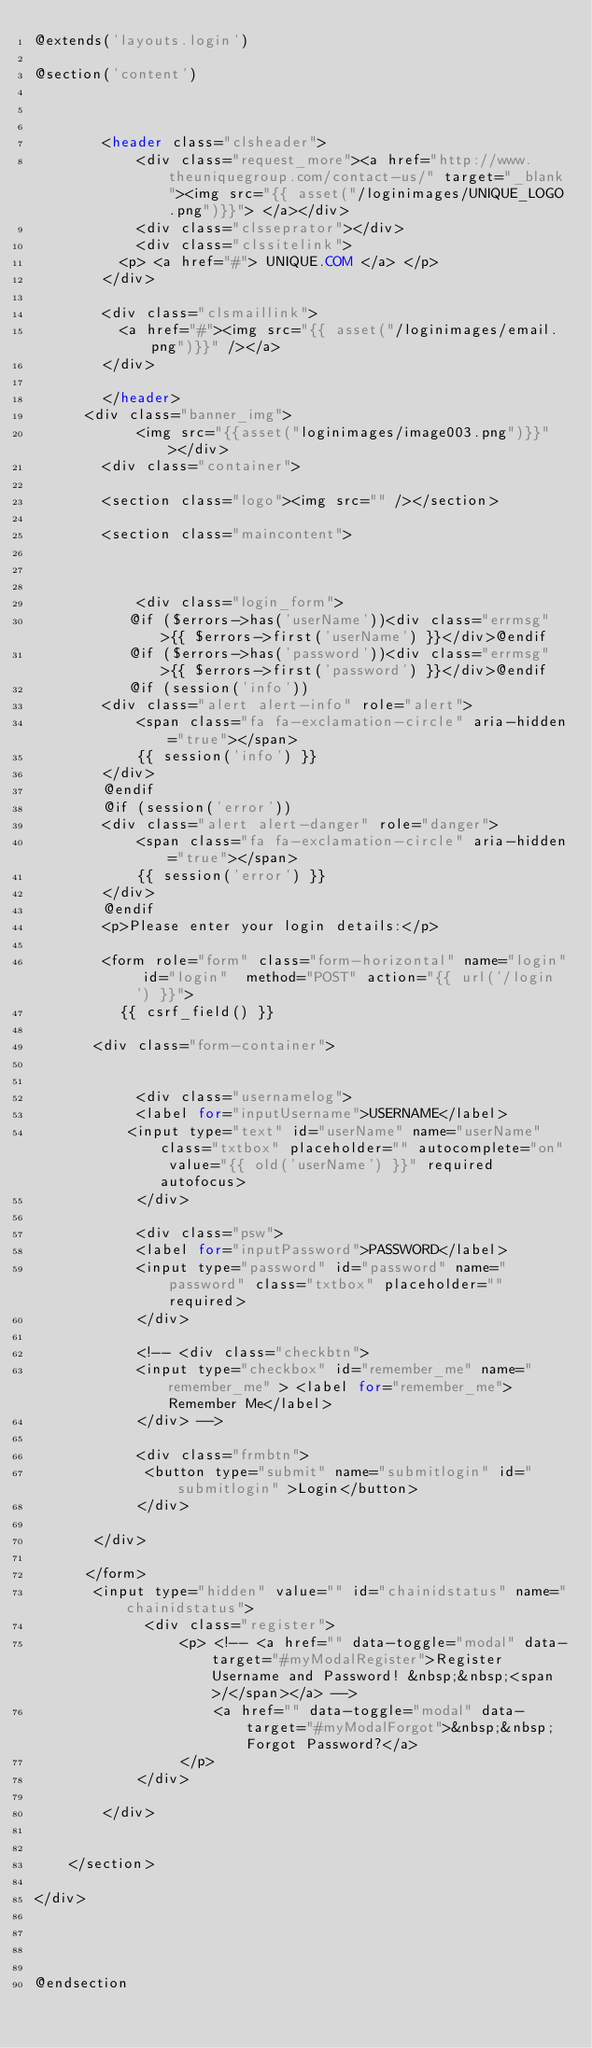Convert code to text. <code><loc_0><loc_0><loc_500><loc_500><_PHP_>@extends('layouts.login')

@section('content')

        
            
        <header class="clsheader">
            <div class="request_more"><a href="http://www.theuniquegroup.com/contact-us/" target="_blank"><img src="{{ asset("/loginimages/UNIQUE_LOGO.png")}}"> </a></div>
            <div class="clsseprator"></div>
            <div class="clssitelink">
          <p> <a href="#"> UNIQUE.COM </a> </p>
        </div>

        <div class="clsmaillink">
          <a href="#"><img src="{{ asset("/loginimages/email.png")}}" /></a>
        </div>
            
        </header>
      <div class="banner_img">
            <img src="{{asset("loginimages/image003.png")}}"></div>
        <div class="container">
          
        <section class="logo"><img src="" /></section>
        
        <section class="maincontent">
                               
            
            
            <div class="login_form">
           @if ($errors->has('userName'))<div class="errmsg">{{ $errors->first('userName') }}</div>@endif
           @if ($errors->has('password'))<div class="errmsg">{{ $errors->first('password') }}</div>@endif
           @if (session('info'))
        <div class="alert alert-info" role="alert">
            <span class="fa fa-exclamation-circle" aria-hidden="true"></span>
            {{ session('info') }}
        </div>
        @endif 
        @if (session('error'))
        <div class="alert alert-danger" role="danger">
            <span class="fa fa-exclamation-circle" aria-hidden="true"></span>
            {{ session('error') }}
        </div>
        @endif
        <p>Please enter your login details:</p>
             
        <form role="form" class="form-horizontal" name="login" id="login"  method="POST" action="{{ url('/login') }}">
          {{ csrf_field() }}
           
       <div class="form-container">

         
            <div class="usernamelog">
            <label for="inputUsername">USERNAME</label>         
           <input type="text" id="userName" name="userName" class="txtbox" placeholder="" autocomplete="on" value="{{ old('userName') }}" required autofocus>
            </div>
            
            <div class="psw">
            <label for="inputPassword">PASSWORD</label>
            <input type="password" id="password" name="password" class="txtbox" placeholder="" required>
            </div>
            
            <!-- <div class="checkbtn">
            <input type="checkbox" id="remember_me" name="remember_me" > <label for="remember_me">Remember Me</label>
            </div> -->
            
            <div class="frmbtn">
             <button type="submit" name="submitlogin" id="submitlogin" >Login</button>
            </div>

       </div>
     
      </form>
       <input type="hidden" value="" id="chainidstatus" name="chainidstatus">
             <div class="register">
                 <p> <!-- <a href="" data-toggle="modal" data-target="#myModalRegister">Register Username and Password! &nbsp;&nbsp;<span>/</span></a> -->
                     <a href="" data-toggle="modal" data-target="#myModalForgot">&nbsp;&nbsp;Forgot Password?</a>
                 </p>
            </div>
          
        </div>

    
    </section>

</div>
          
          
         
      
@endsection
</code> 